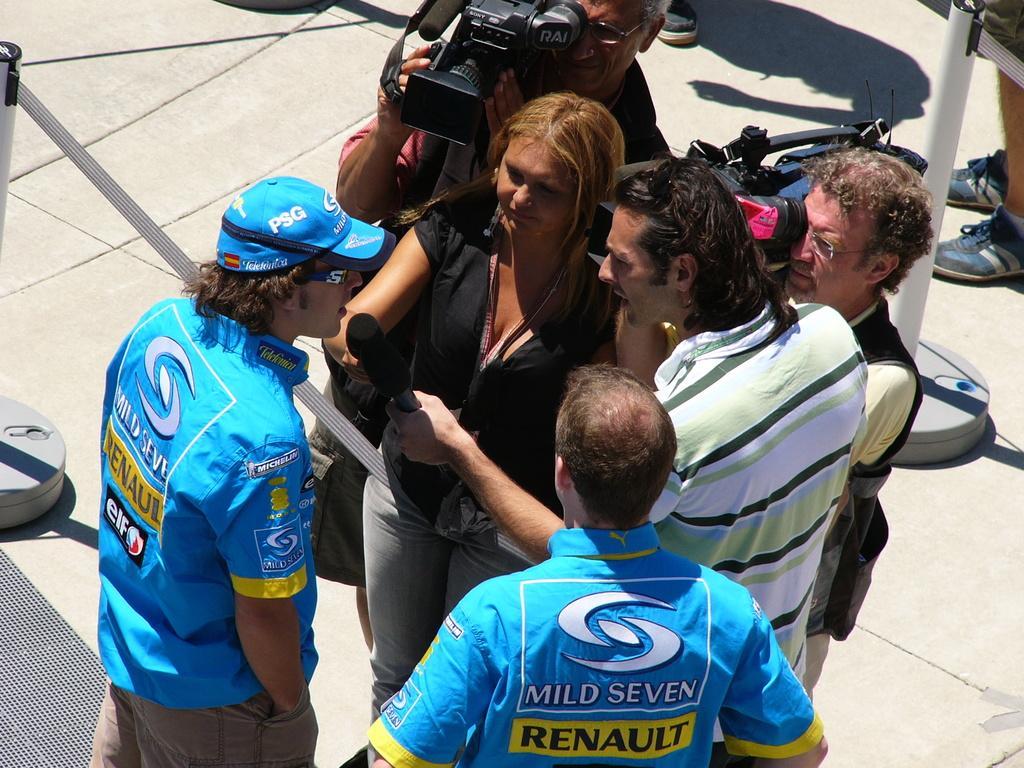In one or two sentences, can you explain what this image depicts? In this picture there is a woman who is wearing black dress and beside her there is a cameraman who is holding a camera. Beside her there is a man who is wearing strip t-shirt and trouser and he is holding a mic. Beside the mic I can see the man who is wearing blue dress. On the right and left side I can see the poles. 